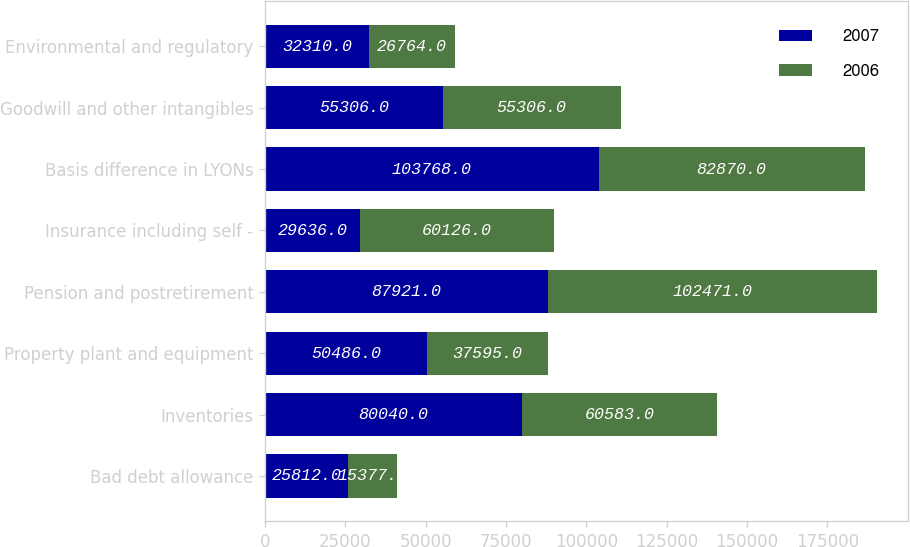Convert chart to OTSL. <chart><loc_0><loc_0><loc_500><loc_500><stacked_bar_chart><ecel><fcel>Bad debt allowance<fcel>Inventories<fcel>Property plant and equipment<fcel>Pension and postretirement<fcel>Insurance including self -<fcel>Basis difference in LYONs<fcel>Goodwill and other intangibles<fcel>Environmental and regulatory<nl><fcel>2007<fcel>25812<fcel>80040<fcel>50486<fcel>87921<fcel>29636<fcel>103768<fcel>55306<fcel>32310<nl><fcel>2006<fcel>15377<fcel>60583<fcel>37595<fcel>102471<fcel>60126<fcel>82870<fcel>55306<fcel>26764<nl></chart> 